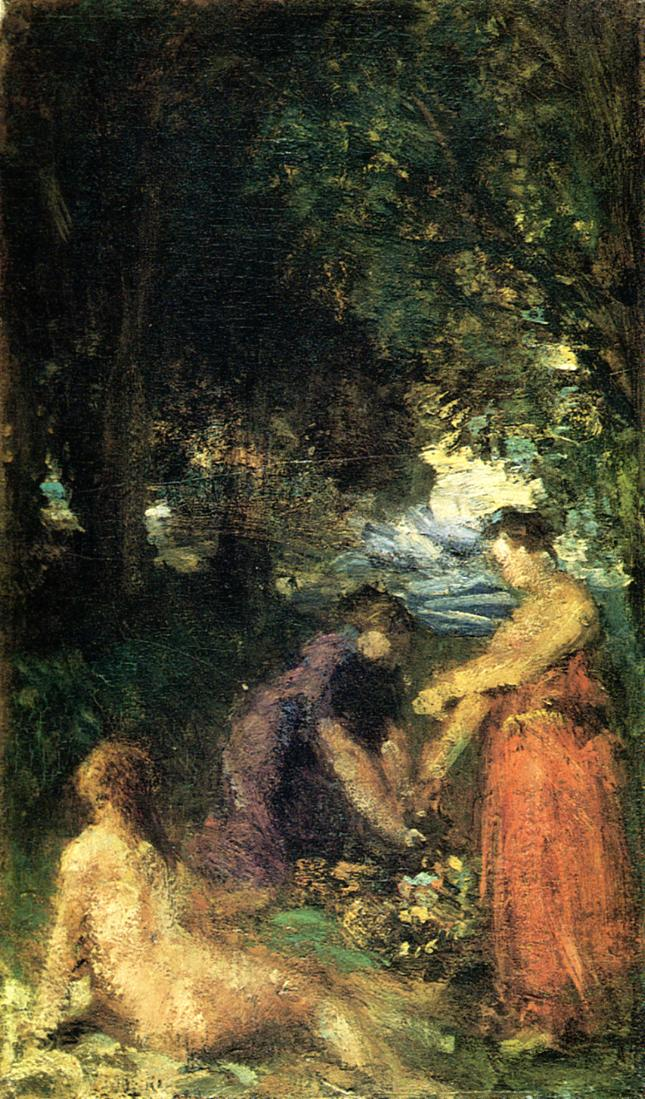Can you describe the mood of this painting? The mood of this painting is tranquil and reflective. The use of subtle hues and the depiction of a serene natural setting with a group of people leisurely gathered suggest a peaceful and contemplative moment. The dappled light filtering through the canopy adds a touch of magic and calmness, inviting the viewer to immerse themselves in the quiet beauty of nature. 